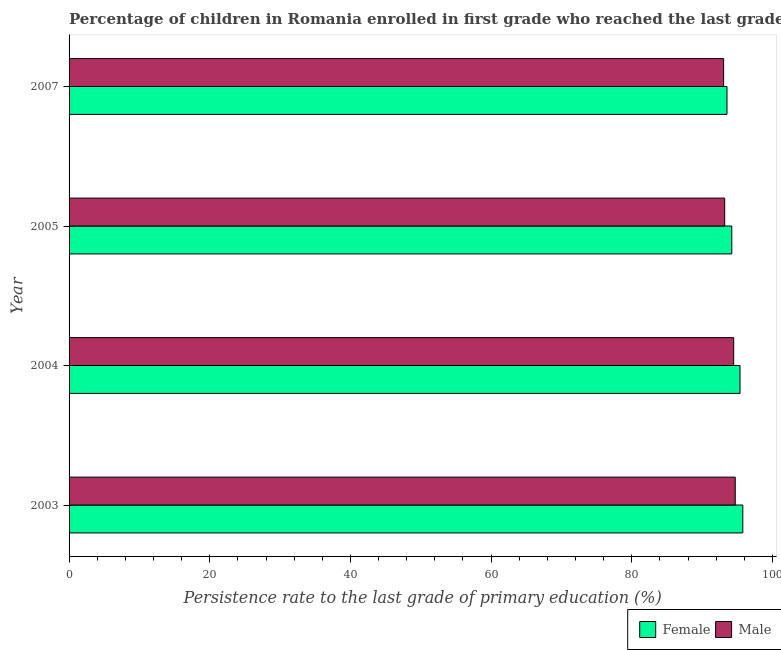How many groups of bars are there?
Provide a short and direct response. 4. Are the number of bars per tick equal to the number of legend labels?
Provide a succinct answer. Yes. Are the number of bars on each tick of the Y-axis equal?
Your response must be concise. Yes. How many bars are there on the 2nd tick from the top?
Your answer should be very brief. 2. What is the persistence rate of female students in 2005?
Your answer should be compact. 94.22. Across all years, what is the maximum persistence rate of male students?
Your answer should be compact. 94.71. Across all years, what is the minimum persistence rate of male students?
Your answer should be compact. 93.06. What is the total persistence rate of male students in the graph?
Offer a very short reply. 375.47. What is the difference between the persistence rate of male students in 2004 and that in 2005?
Your answer should be very brief. 1.28. What is the difference between the persistence rate of female students in 2005 and the persistence rate of male students in 2004?
Make the answer very short. -0.27. What is the average persistence rate of male students per year?
Offer a terse response. 93.87. In the year 2005, what is the difference between the persistence rate of male students and persistence rate of female students?
Offer a terse response. -1.01. In how many years, is the persistence rate of male students greater than 36 %?
Offer a terse response. 4. What is the ratio of the persistence rate of female students in 2003 to that in 2005?
Offer a terse response. 1.02. Is the difference between the persistence rate of male students in 2003 and 2005 greater than the difference between the persistence rate of female students in 2003 and 2005?
Keep it short and to the point. No. What is the difference between the highest and the second highest persistence rate of female students?
Provide a succinct answer. 0.4. What is the difference between the highest and the lowest persistence rate of female students?
Give a very brief answer. 2.25. In how many years, is the persistence rate of female students greater than the average persistence rate of female students taken over all years?
Make the answer very short. 2. Is the sum of the persistence rate of male students in 2004 and 2007 greater than the maximum persistence rate of female students across all years?
Provide a short and direct response. Yes. How many bars are there?
Make the answer very short. 8. Does the graph contain grids?
Keep it short and to the point. No. Where does the legend appear in the graph?
Provide a succinct answer. Bottom right. How many legend labels are there?
Keep it short and to the point. 2. What is the title of the graph?
Offer a very short reply. Percentage of children in Romania enrolled in first grade who reached the last grade of primary education. Does "UN agencies" appear as one of the legend labels in the graph?
Make the answer very short. No. What is the label or title of the X-axis?
Your answer should be very brief. Persistence rate to the last grade of primary education (%). What is the Persistence rate to the last grade of primary education (%) of Female in 2003?
Make the answer very short. 95.78. What is the Persistence rate to the last grade of primary education (%) in Male in 2003?
Offer a terse response. 94.71. What is the Persistence rate to the last grade of primary education (%) in Female in 2004?
Provide a succinct answer. 95.39. What is the Persistence rate to the last grade of primary education (%) of Male in 2004?
Your response must be concise. 94.49. What is the Persistence rate to the last grade of primary education (%) of Female in 2005?
Your answer should be very brief. 94.22. What is the Persistence rate to the last grade of primary education (%) of Male in 2005?
Offer a terse response. 93.21. What is the Persistence rate to the last grade of primary education (%) of Female in 2007?
Your answer should be very brief. 93.54. What is the Persistence rate to the last grade of primary education (%) in Male in 2007?
Provide a short and direct response. 93.06. Across all years, what is the maximum Persistence rate to the last grade of primary education (%) in Female?
Provide a succinct answer. 95.78. Across all years, what is the maximum Persistence rate to the last grade of primary education (%) of Male?
Keep it short and to the point. 94.71. Across all years, what is the minimum Persistence rate to the last grade of primary education (%) of Female?
Make the answer very short. 93.54. Across all years, what is the minimum Persistence rate to the last grade of primary education (%) in Male?
Provide a succinct answer. 93.06. What is the total Persistence rate to the last grade of primary education (%) of Female in the graph?
Give a very brief answer. 378.93. What is the total Persistence rate to the last grade of primary education (%) in Male in the graph?
Provide a succinct answer. 375.47. What is the difference between the Persistence rate to the last grade of primary education (%) in Female in 2003 and that in 2004?
Offer a very short reply. 0.4. What is the difference between the Persistence rate to the last grade of primary education (%) in Male in 2003 and that in 2004?
Your answer should be very brief. 0.22. What is the difference between the Persistence rate to the last grade of primary education (%) of Female in 2003 and that in 2005?
Your answer should be compact. 1.57. What is the difference between the Persistence rate to the last grade of primary education (%) of Male in 2003 and that in 2005?
Offer a very short reply. 1.5. What is the difference between the Persistence rate to the last grade of primary education (%) in Female in 2003 and that in 2007?
Provide a succinct answer. 2.25. What is the difference between the Persistence rate to the last grade of primary education (%) in Male in 2003 and that in 2007?
Your response must be concise. 1.65. What is the difference between the Persistence rate to the last grade of primary education (%) of Female in 2004 and that in 2005?
Give a very brief answer. 1.17. What is the difference between the Persistence rate to the last grade of primary education (%) in Male in 2004 and that in 2005?
Ensure brevity in your answer.  1.28. What is the difference between the Persistence rate to the last grade of primary education (%) in Female in 2004 and that in 2007?
Ensure brevity in your answer.  1.85. What is the difference between the Persistence rate to the last grade of primary education (%) of Male in 2004 and that in 2007?
Make the answer very short. 1.43. What is the difference between the Persistence rate to the last grade of primary education (%) of Female in 2005 and that in 2007?
Your response must be concise. 0.68. What is the difference between the Persistence rate to the last grade of primary education (%) of Male in 2005 and that in 2007?
Offer a very short reply. 0.15. What is the difference between the Persistence rate to the last grade of primary education (%) in Female in 2003 and the Persistence rate to the last grade of primary education (%) in Male in 2004?
Your response must be concise. 1.29. What is the difference between the Persistence rate to the last grade of primary education (%) in Female in 2003 and the Persistence rate to the last grade of primary education (%) in Male in 2005?
Your answer should be very brief. 2.57. What is the difference between the Persistence rate to the last grade of primary education (%) in Female in 2003 and the Persistence rate to the last grade of primary education (%) in Male in 2007?
Provide a short and direct response. 2.73. What is the difference between the Persistence rate to the last grade of primary education (%) of Female in 2004 and the Persistence rate to the last grade of primary education (%) of Male in 2005?
Give a very brief answer. 2.18. What is the difference between the Persistence rate to the last grade of primary education (%) of Female in 2004 and the Persistence rate to the last grade of primary education (%) of Male in 2007?
Your answer should be very brief. 2.33. What is the difference between the Persistence rate to the last grade of primary education (%) in Female in 2005 and the Persistence rate to the last grade of primary education (%) in Male in 2007?
Your answer should be compact. 1.16. What is the average Persistence rate to the last grade of primary education (%) in Female per year?
Offer a terse response. 94.73. What is the average Persistence rate to the last grade of primary education (%) of Male per year?
Give a very brief answer. 93.87. In the year 2003, what is the difference between the Persistence rate to the last grade of primary education (%) in Female and Persistence rate to the last grade of primary education (%) in Male?
Your answer should be very brief. 1.07. In the year 2004, what is the difference between the Persistence rate to the last grade of primary education (%) in Female and Persistence rate to the last grade of primary education (%) in Male?
Ensure brevity in your answer.  0.9. In the year 2007, what is the difference between the Persistence rate to the last grade of primary education (%) of Female and Persistence rate to the last grade of primary education (%) of Male?
Give a very brief answer. 0.48. What is the ratio of the Persistence rate to the last grade of primary education (%) in Female in 2003 to that in 2005?
Keep it short and to the point. 1.02. What is the ratio of the Persistence rate to the last grade of primary education (%) of Male in 2003 to that in 2005?
Provide a succinct answer. 1.02. What is the ratio of the Persistence rate to the last grade of primary education (%) in Male in 2003 to that in 2007?
Make the answer very short. 1.02. What is the ratio of the Persistence rate to the last grade of primary education (%) of Female in 2004 to that in 2005?
Keep it short and to the point. 1.01. What is the ratio of the Persistence rate to the last grade of primary education (%) in Male in 2004 to that in 2005?
Ensure brevity in your answer.  1.01. What is the ratio of the Persistence rate to the last grade of primary education (%) of Female in 2004 to that in 2007?
Provide a succinct answer. 1.02. What is the ratio of the Persistence rate to the last grade of primary education (%) in Male in 2004 to that in 2007?
Your answer should be very brief. 1.02. What is the ratio of the Persistence rate to the last grade of primary education (%) of Female in 2005 to that in 2007?
Give a very brief answer. 1.01. What is the difference between the highest and the second highest Persistence rate to the last grade of primary education (%) in Female?
Offer a terse response. 0.4. What is the difference between the highest and the second highest Persistence rate to the last grade of primary education (%) in Male?
Provide a short and direct response. 0.22. What is the difference between the highest and the lowest Persistence rate to the last grade of primary education (%) in Female?
Keep it short and to the point. 2.25. What is the difference between the highest and the lowest Persistence rate to the last grade of primary education (%) of Male?
Your answer should be very brief. 1.65. 